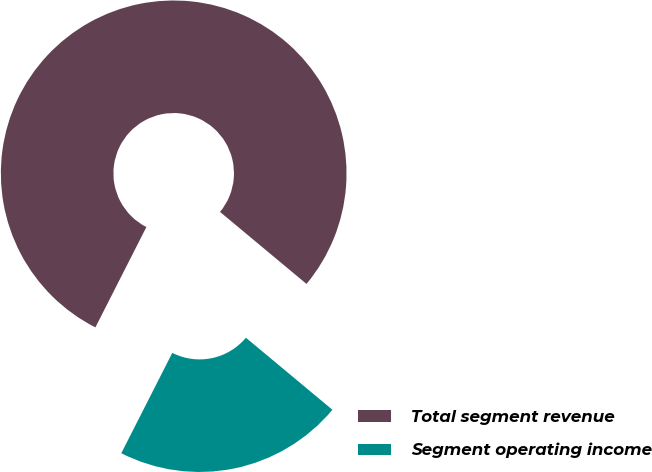Convert chart. <chart><loc_0><loc_0><loc_500><loc_500><pie_chart><fcel>Total segment revenue<fcel>Segment operating income<nl><fcel>78.57%<fcel>21.43%<nl></chart> 